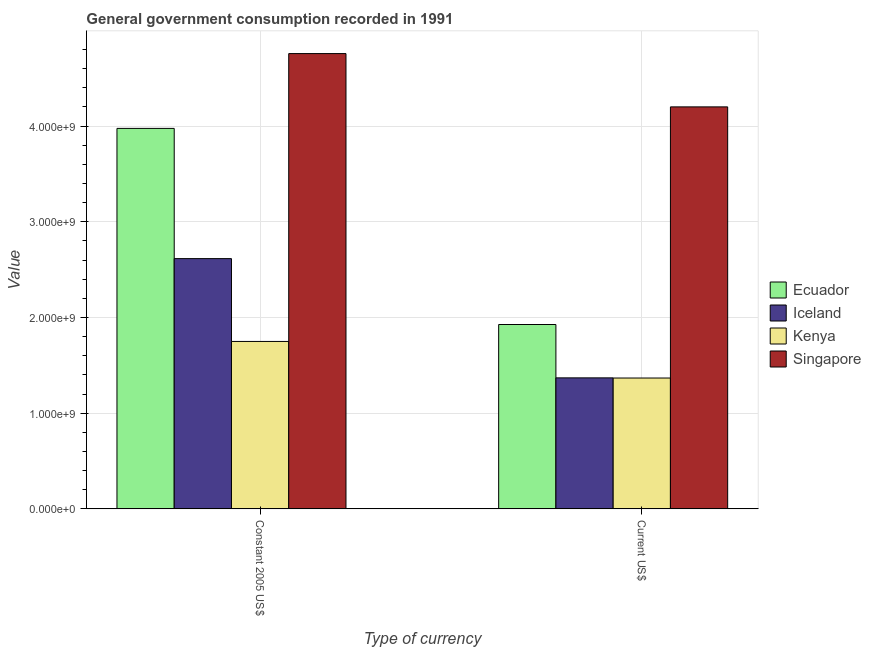How many different coloured bars are there?
Offer a terse response. 4. How many bars are there on the 2nd tick from the left?
Provide a succinct answer. 4. What is the label of the 1st group of bars from the left?
Your answer should be very brief. Constant 2005 US$. What is the value consumed in constant 2005 us$ in Singapore?
Your response must be concise. 4.76e+09. Across all countries, what is the maximum value consumed in current us$?
Keep it short and to the point. 4.20e+09. Across all countries, what is the minimum value consumed in constant 2005 us$?
Make the answer very short. 1.75e+09. In which country was the value consumed in current us$ maximum?
Provide a succinct answer. Singapore. In which country was the value consumed in current us$ minimum?
Your response must be concise. Kenya. What is the total value consumed in current us$ in the graph?
Offer a terse response. 8.86e+09. What is the difference between the value consumed in current us$ in Ecuador and that in Kenya?
Offer a terse response. 5.59e+08. What is the difference between the value consumed in constant 2005 us$ in Singapore and the value consumed in current us$ in Ecuador?
Offer a very short reply. 2.83e+09. What is the average value consumed in constant 2005 us$ per country?
Provide a succinct answer. 3.27e+09. What is the difference between the value consumed in current us$ and value consumed in constant 2005 us$ in Iceland?
Keep it short and to the point. -1.25e+09. In how many countries, is the value consumed in constant 2005 us$ greater than 2000000000 ?
Provide a short and direct response. 3. What is the ratio of the value consumed in constant 2005 us$ in Kenya to that in Ecuador?
Offer a terse response. 0.44. In how many countries, is the value consumed in current us$ greater than the average value consumed in current us$ taken over all countries?
Ensure brevity in your answer.  1. What does the 1st bar from the left in Current US$ represents?
Your response must be concise. Ecuador. What is the title of the graph?
Your answer should be compact. General government consumption recorded in 1991. What is the label or title of the X-axis?
Provide a succinct answer. Type of currency. What is the label or title of the Y-axis?
Your response must be concise. Value. What is the Value in Ecuador in Constant 2005 US$?
Your answer should be very brief. 3.98e+09. What is the Value of Iceland in Constant 2005 US$?
Your answer should be compact. 2.61e+09. What is the Value in Kenya in Constant 2005 US$?
Offer a terse response. 1.75e+09. What is the Value of Singapore in Constant 2005 US$?
Make the answer very short. 4.76e+09. What is the Value in Ecuador in Current US$?
Provide a succinct answer. 1.93e+09. What is the Value in Iceland in Current US$?
Make the answer very short. 1.37e+09. What is the Value of Kenya in Current US$?
Your response must be concise. 1.37e+09. What is the Value of Singapore in Current US$?
Your answer should be compact. 4.20e+09. Across all Type of currency, what is the maximum Value in Ecuador?
Your response must be concise. 3.98e+09. Across all Type of currency, what is the maximum Value of Iceland?
Offer a terse response. 2.61e+09. Across all Type of currency, what is the maximum Value in Kenya?
Your answer should be compact. 1.75e+09. Across all Type of currency, what is the maximum Value in Singapore?
Your response must be concise. 4.76e+09. Across all Type of currency, what is the minimum Value in Ecuador?
Your answer should be compact. 1.93e+09. Across all Type of currency, what is the minimum Value of Iceland?
Provide a short and direct response. 1.37e+09. Across all Type of currency, what is the minimum Value of Kenya?
Make the answer very short. 1.37e+09. Across all Type of currency, what is the minimum Value in Singapore?
Keep it short and to the point. 4.20e+09. What is the total Value in Ecuador in the graph?
Keep it short and to the point. 5.90e+09. What is the total Value in Iceland in the graph?
Make the answer very short. 3.98e+09. What is the total Value of Kenya in the graph?
Provide a short and direct response. 3.12e+09. What is the total Value in Singapore in the graph?
Your response must be concise. 8.96e+09. What is the difference between the Value of Ecuador in Constant 2005 US$ and that in Current US$?
Provide a short and direct response. 2.05e+09. What is the difference between the Value in Iceland in Constant 2005 US$ and that in Current US$?
Make the answer very short. 1.25e+09. What is the difference between the Value in Kenya in Constant 2005 US$ and that in Current US$?
Make the answer very short. 3.82e+08. What is the difference between the Value in Singapore in Constant 2005 US$ and that in Current US$?
Your response must be concise. 5.57e+08. What is the difference between the Value in Ecuador in Constant 2005 US$ and the Value in Iceland in Current US$?
Offer a terse response. 2.61e+09. What is the difference between the Value of Ecuador in Constant 2005 US$ and the Value of Kenya in Current US$?
Keep it short and to the point. 2.61e+09. What is the difference between the Value of Ecuador in Constant 2005 US$ and the Value of Singapore in Current US$?
Your response must be concise. -2.25e+08. What is the difference between the Value in Iceland in Constant 2005 US$ and the Value in Kenya in Current US$?
Provide a short and direct response. 1.25e+09. What is the difference between the Value of Iceland in Constant 2005 US$ and the Value of Singapore in Current US$?
Offer a very short reply. -1.59e+09. What is the difference between the Value of Kenya in Constant 2005 US$ and the Value of Singapore in Current US$?
Provide a succinct answer. -2.45e+09. What is the average Value of Ecuador per Type of currency?
Your answer should be compact. 2.95e+09. What is the average Value in Iceland per Type of currency?
Keep it short and to the point. 1.99e+09. What is the average Value of Kenya per Type of currency?
Ensure brevity in your answer.  1.56e+09. What is the average Value of Singapore per Type of currency?
Your answer should be very brief. 4.48e+09. What is the difference between the Value of Ecuador and Value of Iceland in Constant 2005 US$?
Make the answer very short. 1.36e+09. What is the difference between the Value in Ecuador and Value in Kenya in Constant 2005 US$?
Ensure brevity in your answer.  2.23e+09. What is the difference between the Value of Ecuador and Value of Singapore in Constant 2005 US$?
Ensure brevity in your answer.  -7.82e+08. What is the difference between the Value in Iceland and Value in Kenya in Constant 2005 US$?
Your response must be concise. 8.66e+08. What is the difference between the Value of Iceland and Value of Singapore in Constant 2005 US$?
Provide a short and direct response. -2.14e+09. What is the difference between the Value in Kenya and Value in Singapore in Constant 2005 US$?
Offer a terse response. -3.01e+09. What is the difference between the Value in Ecuador and Value in Iceland in Current US$?
Provide a short and direct response. 5.58e+08. What is the difference between the Value of Ecuador and Value of Kenya in Current US$?
Make the answer very short. 5.59e+08. What is the difference between the Value in Ecuador and Value in Singapore in Current US$?
Provide a short and direct response. -2.27e+09. What is the difference between the Value in Iceland and Value in Kenya in Current US$?
Make the answer very short. 1.61e+06. What is the difference between the Value of Iceland and Value of Singapore in Current US$?
Your response must be concise. -2.83e+09. What is the difference between the Value of Kenya and Value of Singapore in Current US$?
Your answer should be very brief. -2.83e+09. What is the ratio of the Value in Ecuador in Constant 2005 US$ to that in Current US$?
Provide a succinct answer. 2.06. What is the ratio of the Value of Iceland in Constant 2005 US$ to that in Current US$?
Your answer should be very brief. 1.91. What is the ratio of the Value of Kenya in Constant 2005 US$ to that in Current US$?
Make the answer very short. 1.28. What is the ratio of the Value in Singapore in Constant 2005 US$ to that in Current US$?
Your answer should be very brief. 1.13. What is the difference between the highest and the second highest Value in Ecuador?
Provide a succinct answer. 2.05e+09. What is the difference between the highest and the second highest Value in Iceland?
Give a very brief answer. 1.25e+09. What is the difference between the highest and the second highest Value in Kenya?
Give a very brief answer. 3.82e+08. What is the difference between the highest and the second highest Value of Singapore?
Keep it short and to the point. 5.57e+08. What is the difference between the highest and the lowest Value in Ecuador?
Your answer should be very brief. 2.05e+09. What is the difference between the highest and the lowest Value of Iceland?
Provide a succinct answer. 1.25e+09. What is the difference between the highest and the lowest Value of Kenya?
Provide a succinct answer. 3.82e+08. What is the difference between the highest and the lowest Value in Singapore?
Your answer should be compact. 5.57e+08. 